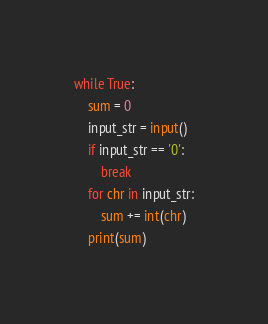<code> <loc_0><loc_0><loc_500><loc_500><_Python_>while True:
    sum = 0
    input_str = input()
    if input_str == '0':
        break
    for chr in input_str:
        sum += int(chr)
    print(sum)

</code> 